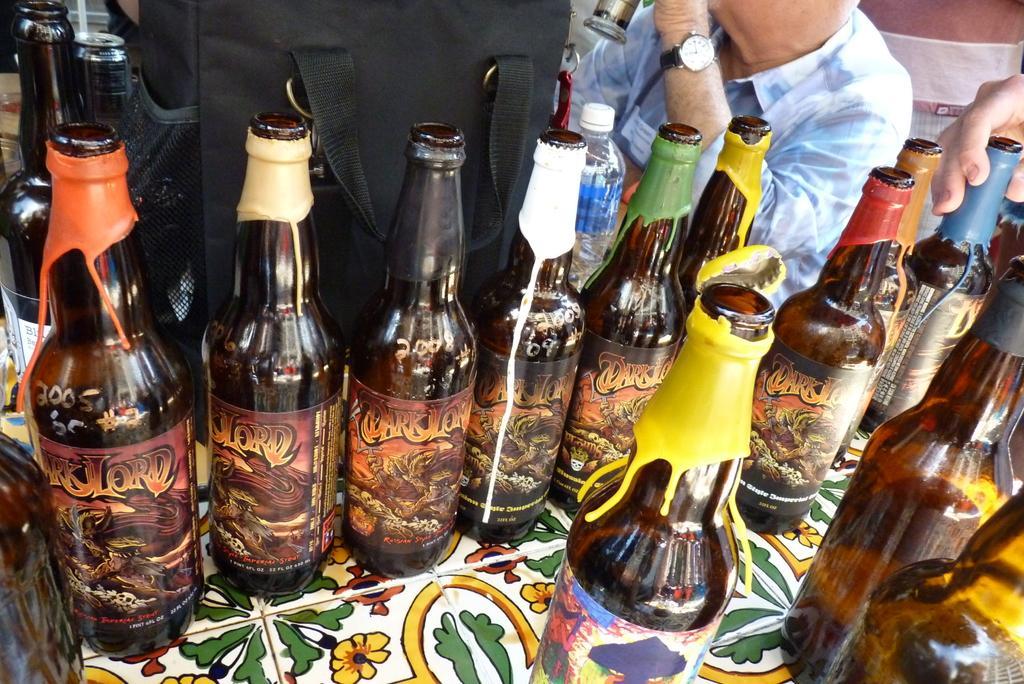Could you give a brief overview of what you see in this image? In this picture we can see bottles with stickers placed on a table and beside to this we have bag, tin and a person wore watch and here some persons hand is holding bottle. 